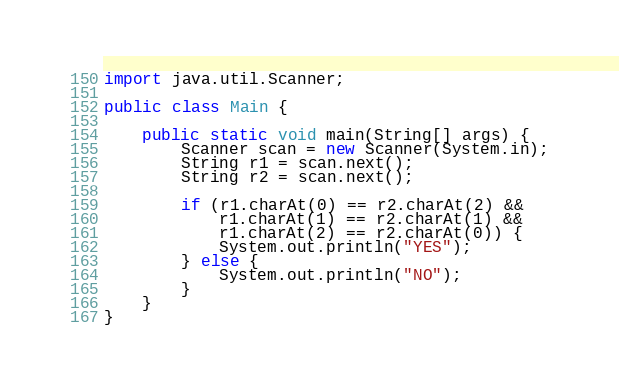Convert code to text. <code><loc_0><loc_0><loc_500><loc_500><_Java_>import java.util.Scanner;

public class Main {

    public static void main(String[] args) {
        Scanner scan = new Scanner(System.in);
        String r1 = scan.next();
        String r2 = scan.next();

        if (r1.charAt(0) == r2.charAt(2) &&
            r1.charAt(1) == r2.charAt(1) &&
            r1.charAt(2) == r2.charAt(0)) {
            System.out.println("YES");
        } else {
            System.out.println("NO");
        }
    }
}

</code> 